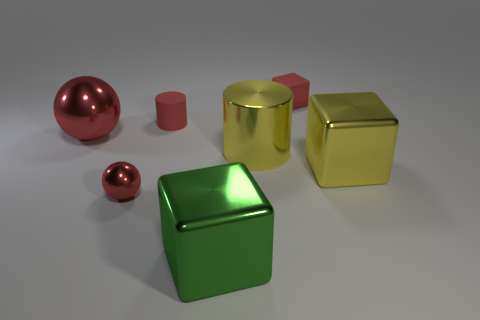What is the size of the shiny block that is the same color as the large metal cylinder?
Your answer should be compact. Large. What number of objects have the same color as the large shiny cylinder?
Give a very brief answer. 1. Is the color of the block right of the rubber block the same as the large cylinder?
Make the answer very short. Yes. Do the big shiny ball and the small block have the same color?
Make the answer very short. Yes. The small thing right of the large cylinder is what color?
Make the answer very short. Red. Are there any shiny balls that have the same size as the matte cylinder?
Your response must be concise. Yes. There is a red block that is the same size as the red cylinder; what is it made of?
Your response must be concise. Rubber. What number of objects are either tiny red objects behind the tiny red shiny sphere or red spheres in front of the large metallic sphere?
Your response must be concise. 3. Are there any large yellow shiny objects that have the same shape as the tiny metallic thing?
Provide a succinct answer. No. There is a block that is the same color as the metallic cylinder; what is its material?
Keep it short and to the point. Metal. 